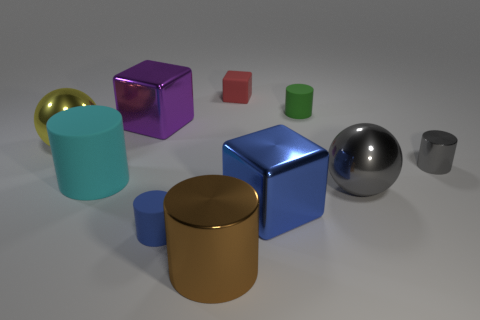Subtract all gray cylinders. How many cylinders are left? 4 Subtract all red cylinders. Subtract all cyan blocks. How many cylinders are left? 5 Subtract all blocks. How many objects are left? 7 Add 5 large blue metal objects. How many large blue metal objects are left? 6 Add 3 small yellow shiny cylinders. How many small yellow shiny cylinders exist? 3 Subtract 1 gray spheres. How many objects are left? 9 Subtract all small blue rubber cylinders. Subtract all cubes. How many objects are left? 6 